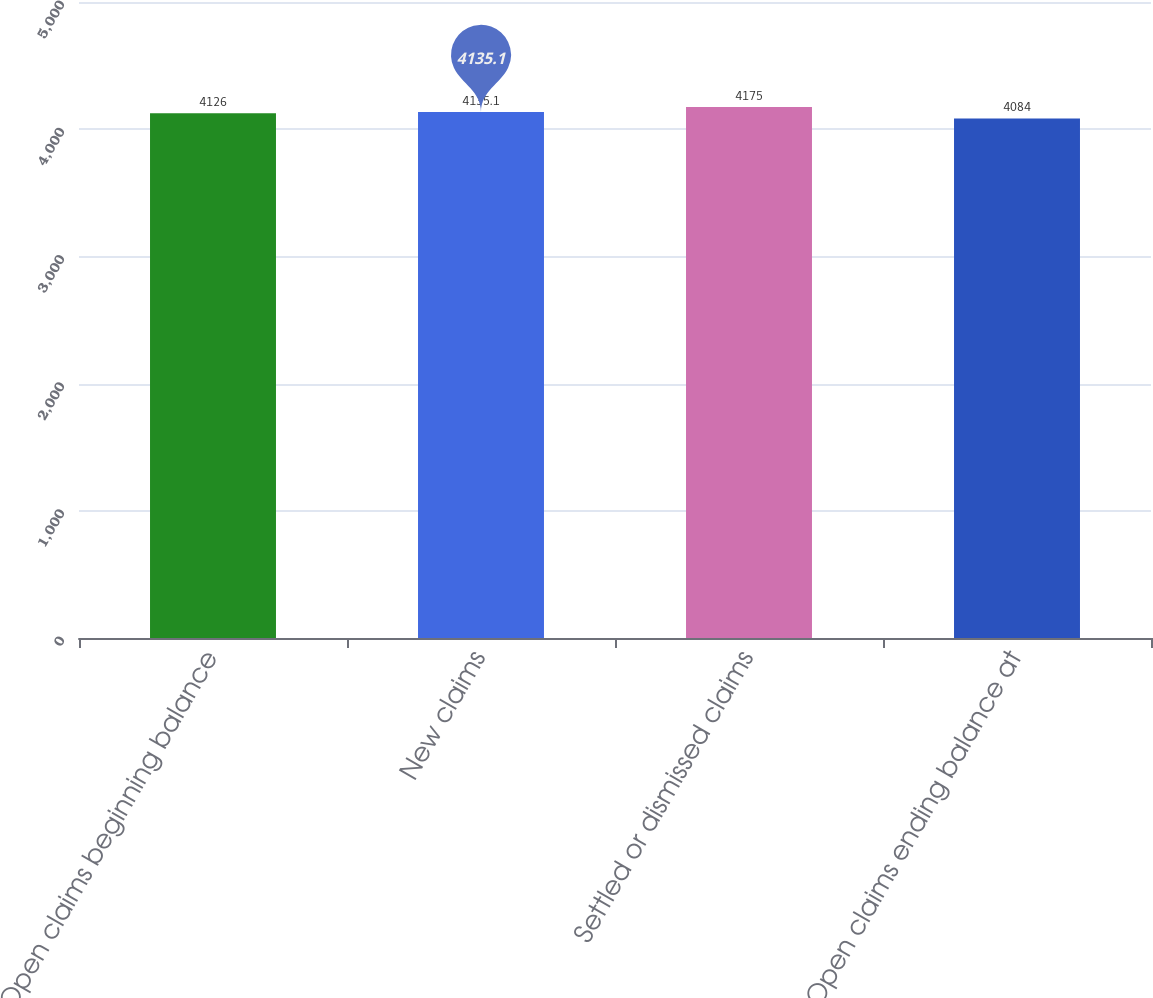Convert chart to OTSL. <chart><loc_0><loc_0><loc_500><loc_500><bar_chart><fcel>Open claims beginning balance<fcel>New claims<fcel>Settled or dismissed claims<fcel>Open claims ending balance at<nl><fcel>4126<fcel>4135.1<fcel>4175<fcel>4084<nl></chart> 